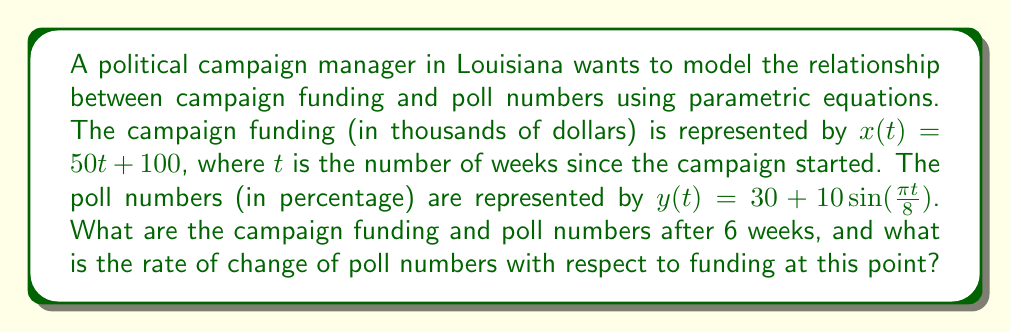Provide a solution to this math problem. Let's approach this problem step by step:

1) First, we need to find the campaign funding and poll numbers after 6 weeks. We do this by substituting $t = 6$ into our parametric equations.

   For campaign funding: 
   $x(6) = 50(6) + 100 = 400$ thousand dollars

   For poll numbers:
   $y(6) = 30 + 10\sin(\frac{\pi (6)}{8}) = 30 + 10\sin(\frac{3\pi}{4}) \approx 37.07\%$

2) Now, to find the rate of change of poll numbers with respect to funding, we need to use the chain rule:

   $$\frac{dy}{dx} = \frac{dy/dt}{dx/dt}$$

3) Let's find $\frac{dx}{dt}$ and $\frac{dy}{dt}$:

   $\frac{dx}{dt} = 50$ (the derivative of $50t + 100$)

   $\frac{dy}{dt} = 10 \cdot \frac{\pi}{8} \cos(\frac{\pi t}{8})$ (the derivative of $30 + 10\sin(\frac{\pi t}{8})$)

4) Now we can substitute these into our chain rule equation:

   $$\frac{dy}{dx} = \frac{10 \cdot \frac{\pi}{8} \cos(\frac{\pi t}{8})}{50}$$

5) Simplify:

   $$\frac{dy}{dx} = \frac{\pi}{40} \cos(\frac{\pi t}{8})$$

6) Now, we evaluate this at $t = 6$:

   $$\frac{dy}{dx} = \frac{\pi}{40} \cos(\frac{3\pi}{4}) \approx -0.0552$$

This negative value indicates that at 6 weeks, as funding increases, poll numbers are slightly decreasing.
Answer: After 6 weeks, campaign funding is $400,000 and poll numbers are approximately 37.07%. The rate of change of poll numbers with respect to funding at this point is approximately -0.0552% per thousand dollars. 